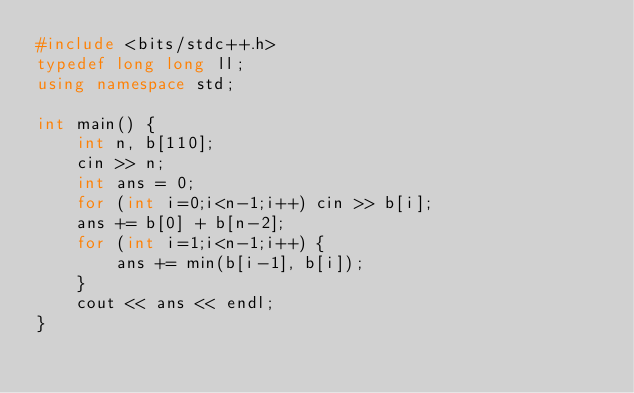Convert code to text. <code><loc_0><loc_0><loc_500><loc_500><_C++_>#include <bits/stdc++.h>
typedef long long ll;
using namespace std;

int main() {
    int n, b[110];
    cin >> n;
    int ans = 0;
    for (int i=0;i<n-1;i++) cin >> b[i];
    ans += b[0] + b[n-2];
    for (int i=1;i<n-1;i++) {
        ans += min(b[i-1], b[i]);
    }
    cout << ans << endl;
}</code> 